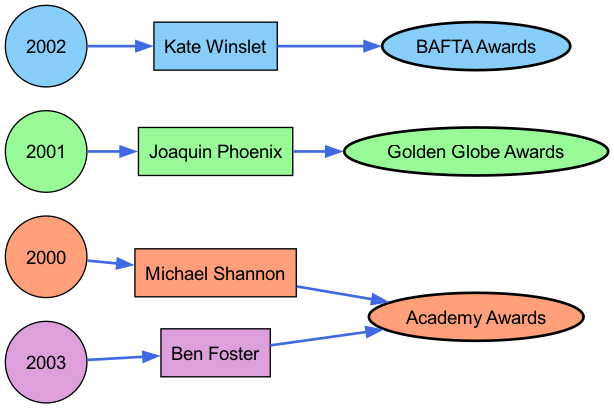What actors are represented in the diagram? The diagram shows four actors: Michael Shannon, Joaquin Phoenix, Kate Winslet, and Ben Foster. These actors are highlighted under their corresponding years.
Answer: Michael Shannon, Joaquin Phoenix, Kate Winslet, Ben Foster How many years are represented in the diagram? The diagram includes the years 2000, 2001, 2002, and 2003, making a total of four years represented.
Answer: 4 Which actor received an Oscar in 2000? The diagram indicates that Michael Shannon is connected to the Oscars for the year 2000.
Answer: Michael Shannon What award did Joaquin Phoenix receive in 2001? According to the diagram, Joaquin Phoenix is linked to the Golden Globe Awards for the year 2001.
Answer: Golden Globe Awards Which actor was awarded a BAFTA in 2002? The diagram shows that Kate Winslet has a connection to the BAFTA Awards for the year 2002.
Answer: Kate Winslet Which years are associated with the Oscars? The years associated with the Oscars are 2000 and 2003, as illustrated by the flow connecting these years to the Oscars node.
Answer: 2000, 2003 How many total connections are there from years to actors? Each year in the diagram connects to one actor; with four years represented, there are four total connections from years to actors.
Answer: 4 Which award is linked to Ben Foster in 2003? The diagram indicates that Ben Foster is connected to the Oscars for the year 2003.
Answer: Oscars What is the flow direction of the diagram? The flow in the diagram moves from years to actors and then from actors to specific awards, indicating a left-to-right direction.
Answer: Left to right 